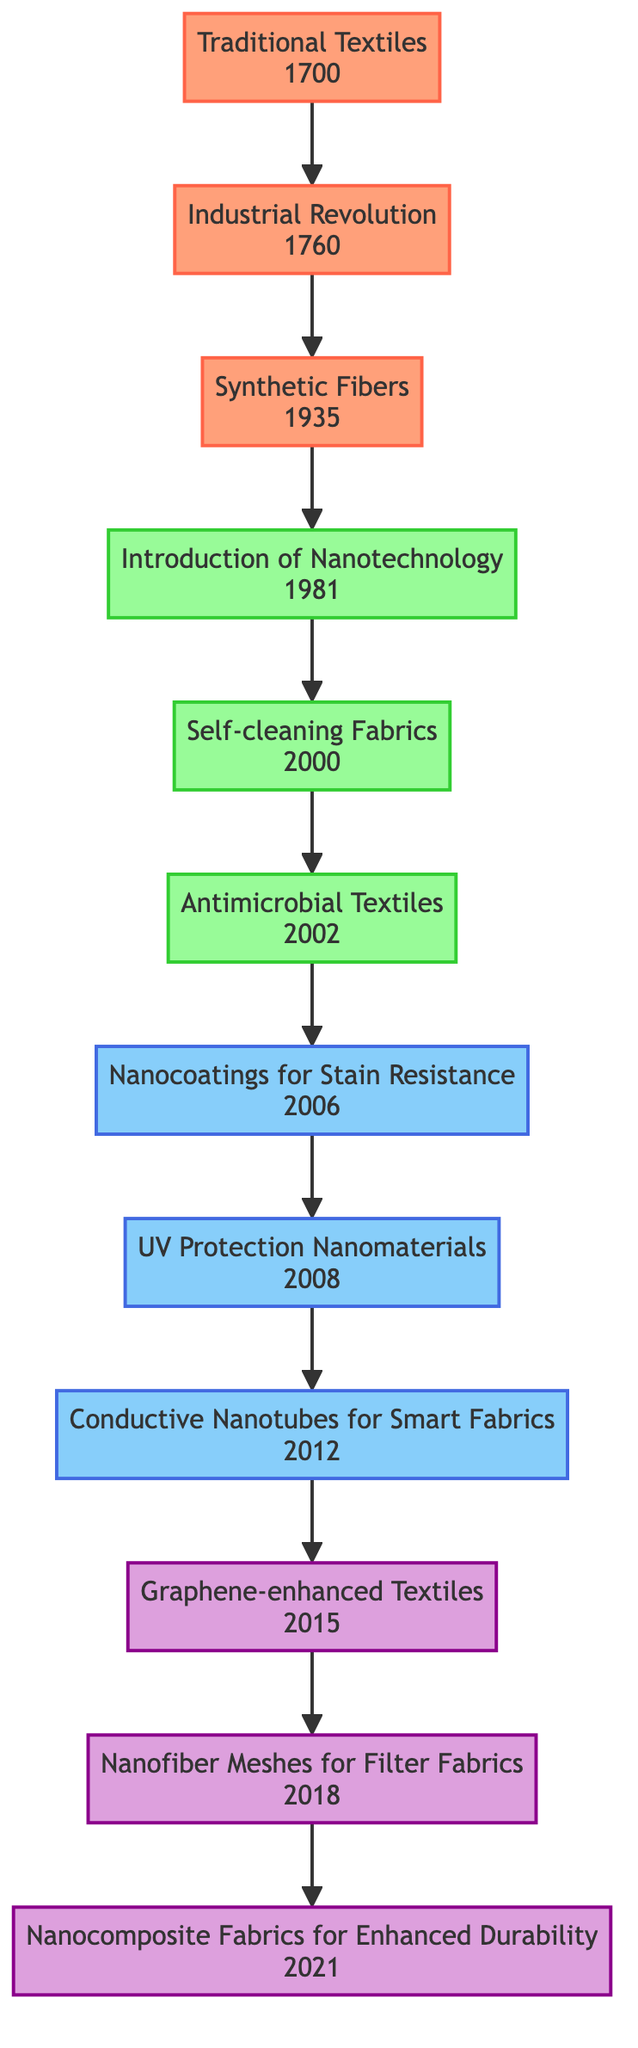What was the first milestone in the evolution of textile manufacturing techniques? The diagram indicates that the first milestone is the "Introduction of Nanotechnology" which occurred in 1981.
Answer: Introduction of Nanotechnology How many innovations are listed in the diagram? The diagram outlines three innovations: "Nanocoatings for Stain Resistance," "UV Protection Nanomaterials," and "Conductive Nanotubes for Smart Fabrics." This leads us to count three innovations.
Answer: 3 Which foundation directly leads to the introduction of nanotechnology? Analyzing the diagram, the "Industrial Revolution" directly precedes the "Introduction of Nanotechnology," which indicates that it is the foundation leading to that milestone.
Answer: Industrial Revolution What year did self-cleaning fabrics become a milestone? Looking at the diagram, the milestone "Self-cleaning Fabrics" was established in 2000.
Answer: 2000 Which current technology was introduced most recently? The diagram illustrates that "Nanocomposite Fabrics for Enhanced Durability" was introduced in 2021, making it the most recent current technology listed.
Answer: Nanocomposite Fabrics for Enhanced Durability How many foundations are depicted in the diagram? Upon examination, there are three foundations listed: "Traditional Textiles," "Industrial Revolution," and "Synthetic Fibers," which means there are a total of three foundations.
Answer: 3 Which innovation is related to UV protection? The diagram mentions "UV Protection Nanomaterials," indicating this is the innovation specifically related to UV protection.
Answer: UV Protection Nanomaterials What is the relationship between antimicrobial textiles and nanotechnology in the diagram? The diagram shows that "Antimicrobial Textiles" is a milestone that follows the introduction of nanotechnology, emphasizing that it is a result of advancements in nanotech.
Answer: Antimicrobial Textiles What do the colored nodes in the diagram represent? The colored nodes represent different categories in the evolution of textile manufacturing: foundations, milestones, innovations, and current technologies, indicating their respective roles in the timeline.
Answer: Different categories 